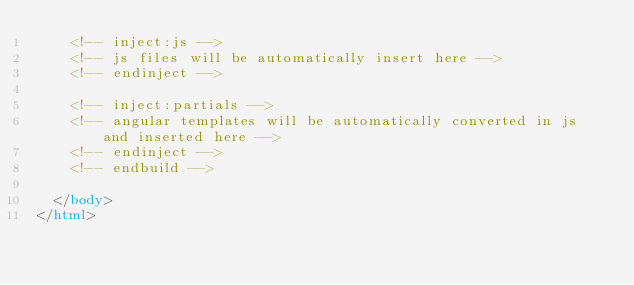<code> <loc_0><loc_0><loc_500><loc_500><_HTML_>    <!-- inject:js -->
    <!-- js files will be automatically insert here -->
    <!-- endinject -->

    <!-- inject:partials -->
    <!-- angular templates will be automatically converted in js and inserted here -->
    <!-- endinject -->
    <!-- endbuild -->

  </body>
</html>
</code> 